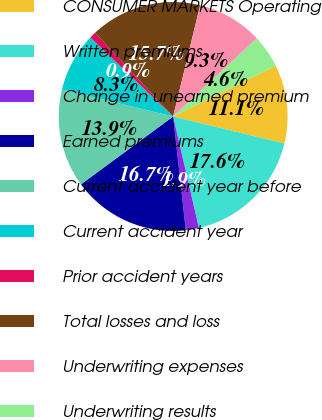<chart> <loc_0><loc_0><loc_500><loc_500><pie_chart><fcel>CONSUMER MARKETS Operating<fcel>Written premiums<fcel>Change in unearned premium<fcel>Earned premiums<fcel>Current accident year before<fcel>Current accident year<fcel>Prior accident years<fcel>Total losses and loss<fcel>Underwriting expenses<fcel>Underwriting results<nl><fcel>11.11%<fcel>17.59%<fcel>1.85%<fcel>16.67%<fcel>13.89%<fcel>8.33%<fcel>0.93%<fcel>15.74%<fcel>9.26%<fcel>4.63%<nl></chart> 